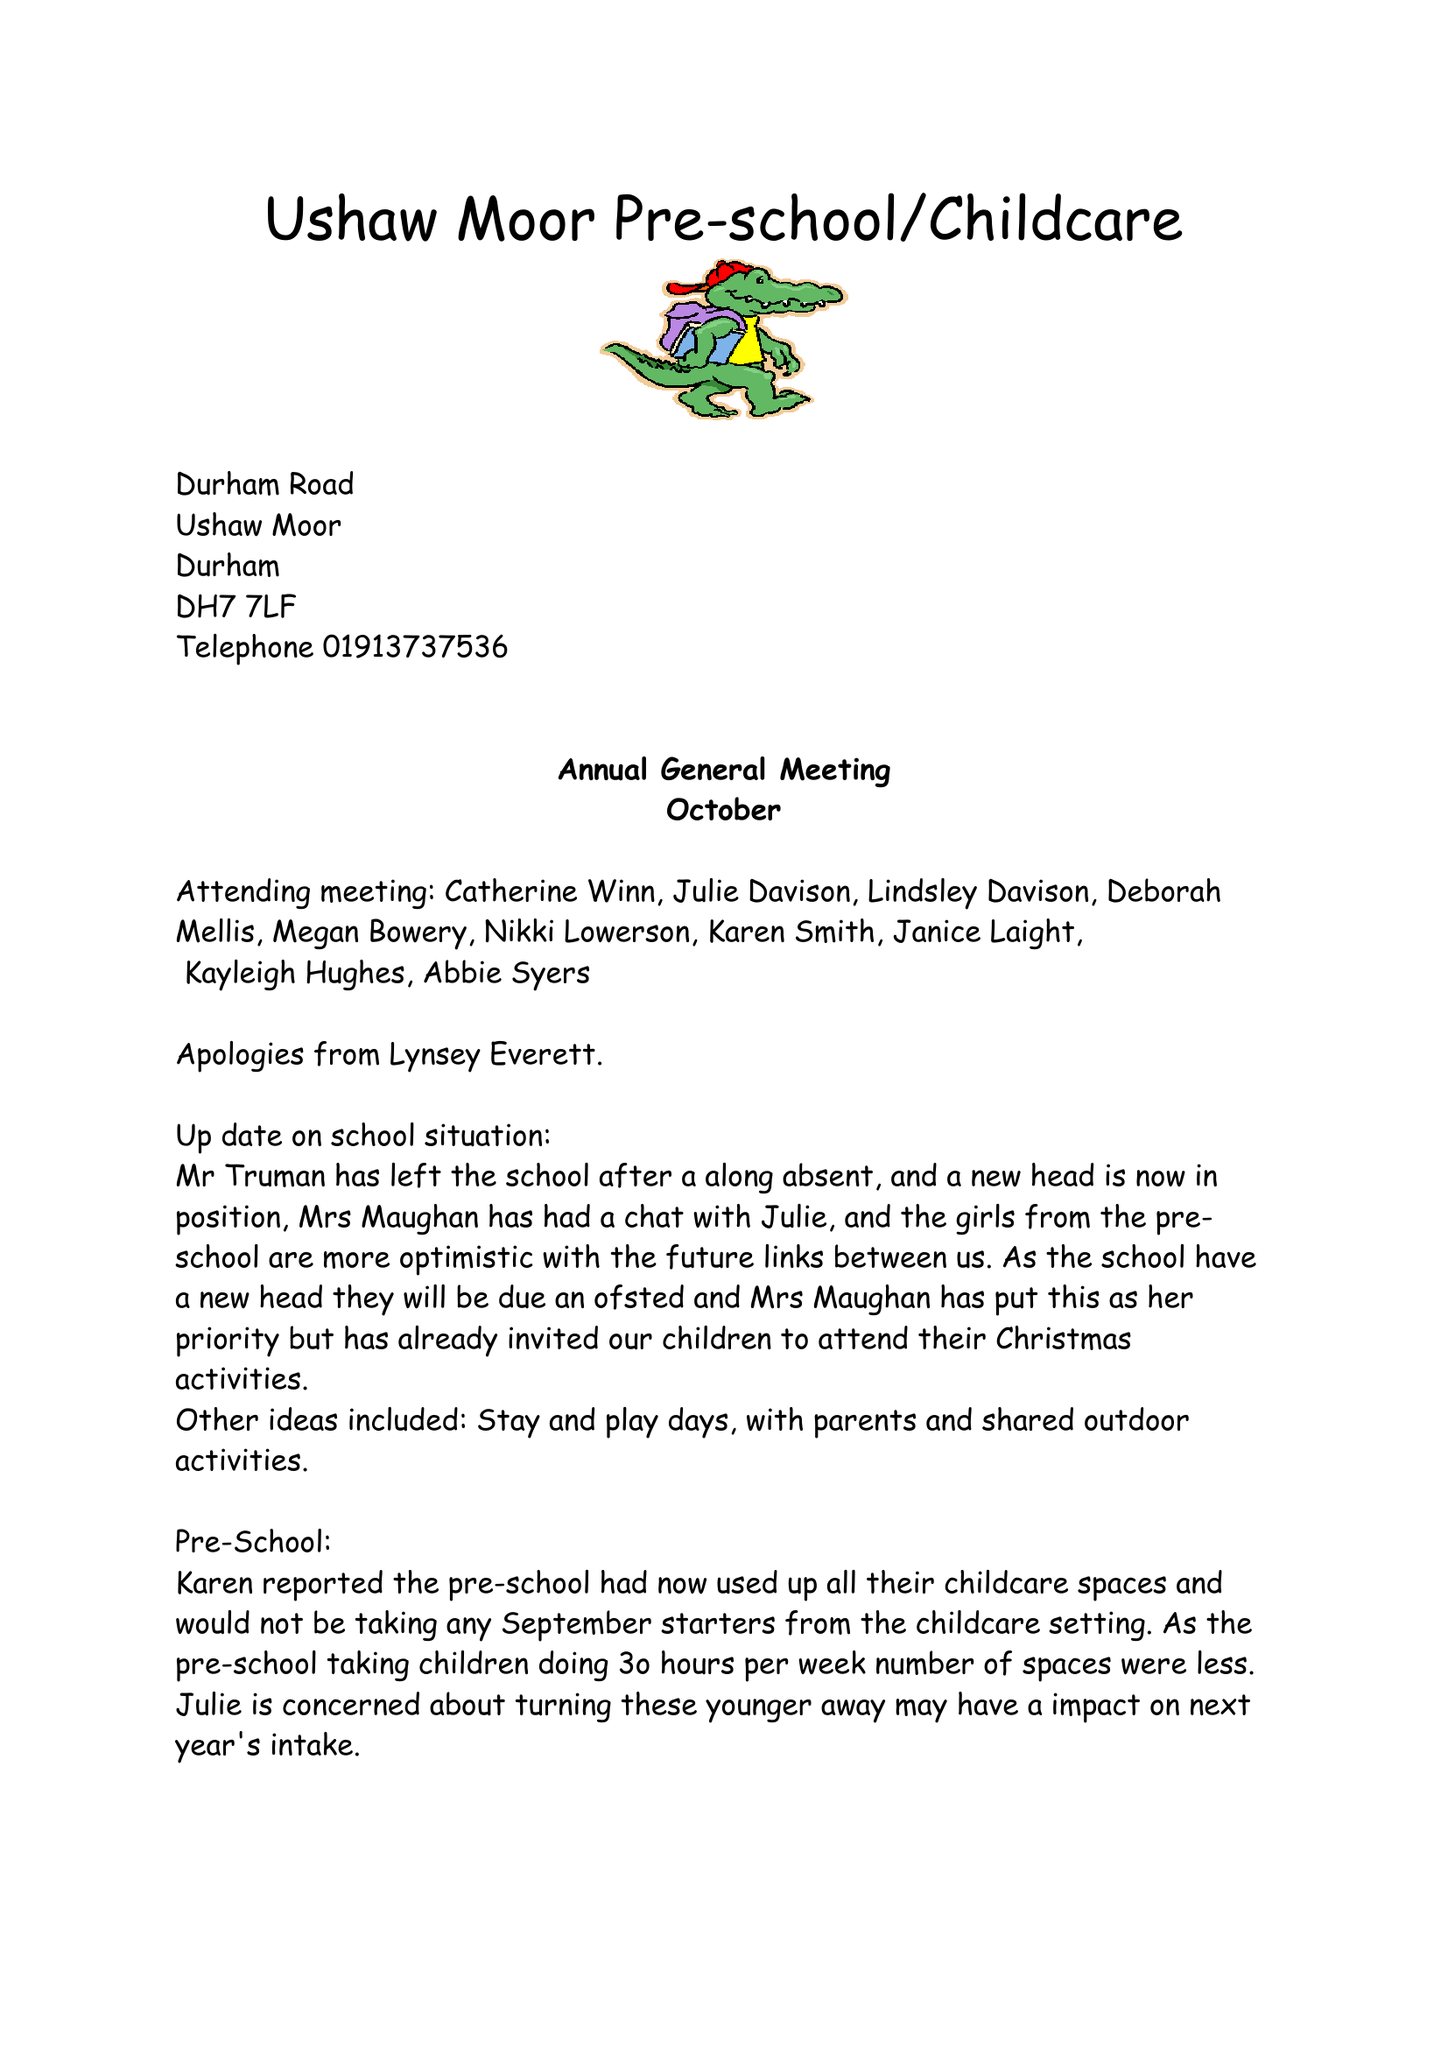What is the value for the address__postcode?
Answer the question using a single word or phrase. DH7 7ND 